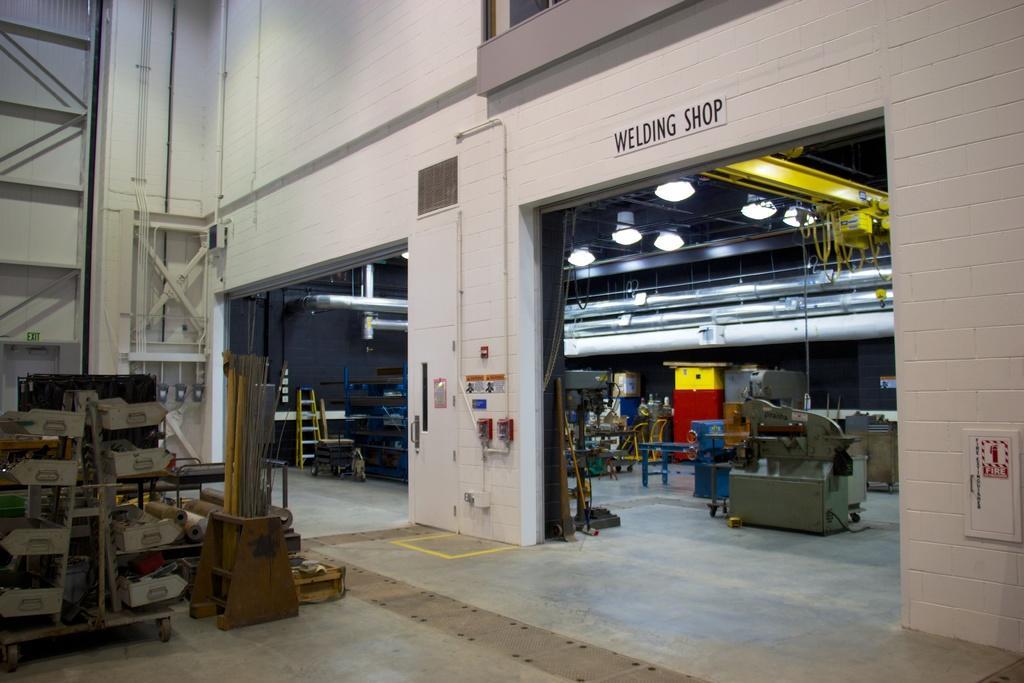Please provide a concise description of this image. In this picture I can see a ladder , machines, lights , a board and some other items in a shed. 